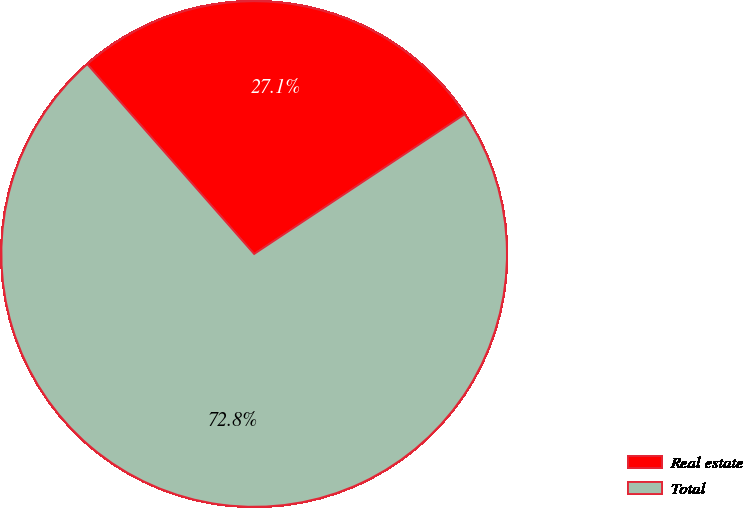Convert chart. <chart><loc_0><loc_0><loc_500><loc_500><pie_chart><fcel>Real estate<fcel>Total<nl><fcel>27.15%<fcel>72.85%<nl></chart> 